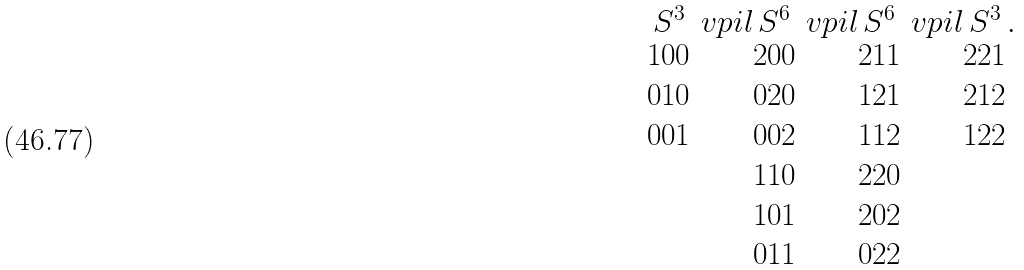<formula> <loc_0><loc_0><loc_500><loc_500>\underset { \begin{matrix} 1 0 0 \\ 0 1 0 \\ 0 0 1 \end{matrix} } { S ^ { 3 } } \ v p i l \underset { \begin{matrix} 2 0 0 \\ 0 2 0 \\ 0 0 2 \\ 1 1 0 \\ 1 0 1 \\ 0 1 1 \end{matrix} } { S ^ { 6 } } \ v p i l \underset { \begin{matrix} 2 1 1 \\ 1 2 1 \\ 1 1 2 \\ 2 2 0 \\ 2 0 2 \\ 0 2 2 \end{matrix} } { S ^ { 6 } } \ v p i l \underset { \begin{matrix} 2 2 1 \\ 2 1 2 \\ 1 2 2 \end{matrix} } { S ^ { 3 } } .</formula> 